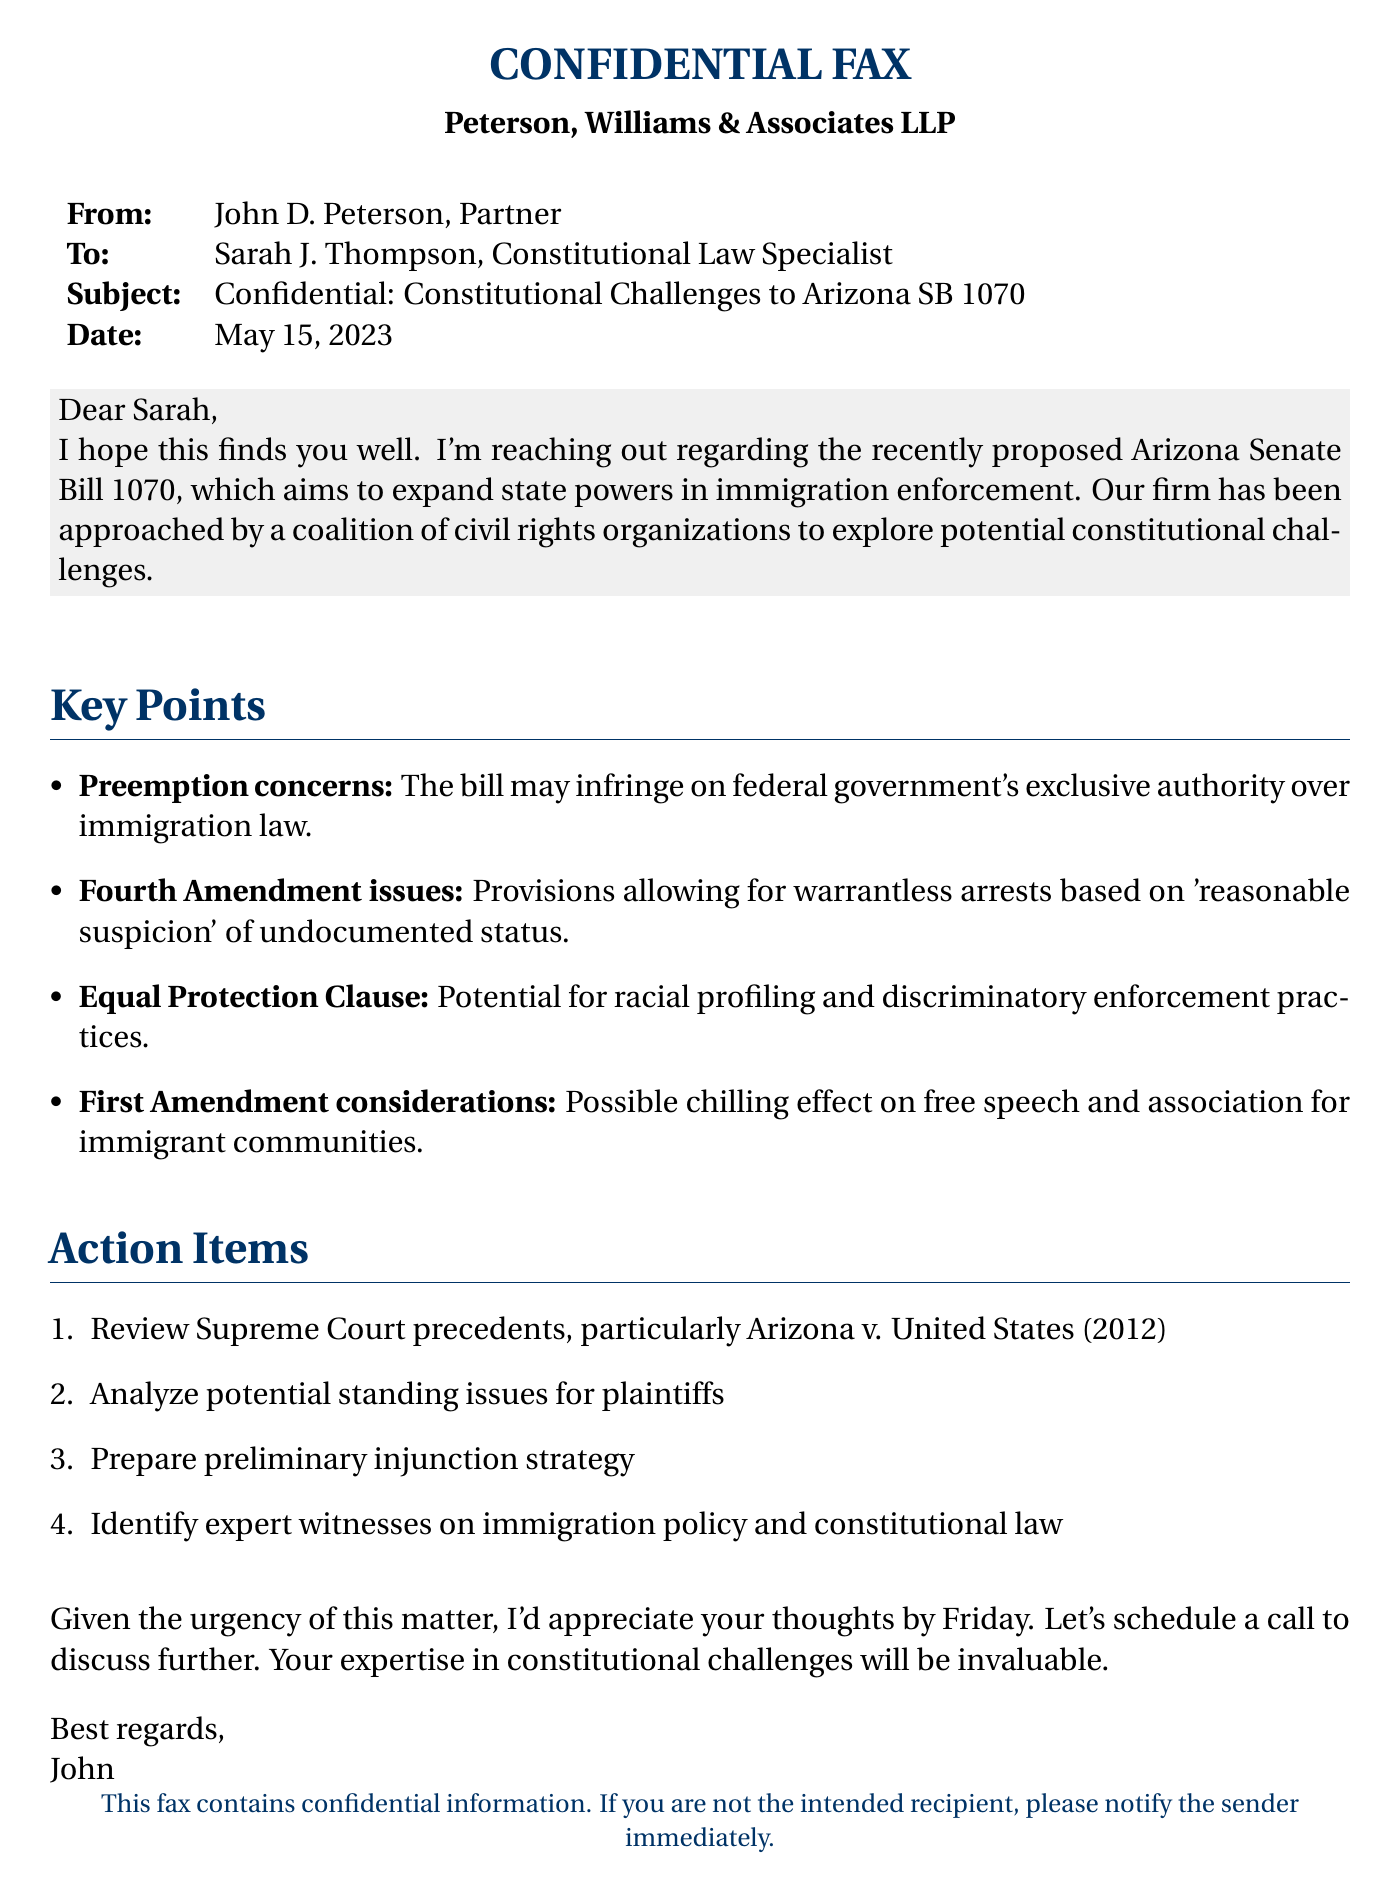What is the subject of the fax? The subject line of the fax indicates the main topic being discussed, which is constitutional challenges to a specific proposed legislation.
Answer: Constitutional Challenges to Arizona SB 1070 Who is the sender of the fax? The sender's name is listed at the beginning of the document, under "From."
Answer: John D. Peterson What is the date of the fax? The date can be found under the "Date" section of the fax.
Answer: May 15, 2023 What is one of the key points raised in the fax? The document outlines several key points, providing insights into the potential challenges posed by the proposed legislation.
Answer: Preemption concerns Which amendment is mentioned in relation to warrantless arrests? The relevant amendment can be identified from the key points section discussing the implications of the bill.
Answer: Fourth Amendment What significant court case is suggested to review? The recommended court case that may provide relevant legal precedents is specified in the action items section.
Answer: Arizona v. United States (2012) How many action items are listed in the fax? The document outlines a specific number of tasks that need to be completed, as listed under the action items section.
Answer: Four Who is the recipient of the fax? The recipient's name is detailed under the "To" section of the fax.
Answer: Sarah J. Thompson What is the firm name mentioned in the fax? The name of the law firm is provided at the beginning of the document.
Answer: Peterson, Williams & Associates LLP 